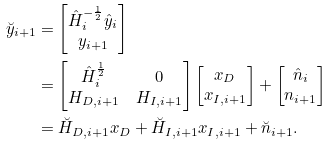<formula> <loc_0><loc_0><loc_500><loc_500>\breve { y } _ { i + 1 } & = \begin{bmatrix} \hat { H } _ { i } ^ { - \frac { 1 } { 2 } } \hat { y } _ { i } \\ y _ { i + 1 } \end{bmatrix} \\ & = \begin{bmatrix} \hat { H } _ { i } ^ { \frac { 1 } { 2 } } & 0 \\ H _ { D , i + 1 } & H _ { I , i + 1 } \end{bmatrix} \begin{bmatrix} x _ { D } \\ x _ { I , { i + 1 } } \end{bmatrix} + \begin{bmatrix} \hat { n } _ { i } \\ n _ { i + 1 } \end{bmatrix} \\ & = \breve { H } _ { D , i + 1 } x _ { D } + \breve { H } _ { I , i + 1 } x _ { I , i + 1 } + \breve { n } _ { i + 1 } .</formula> 